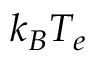<formula> <loc_0><loc_0><loc_500><loc_500>k _ { B } T _ { e }</formula> 